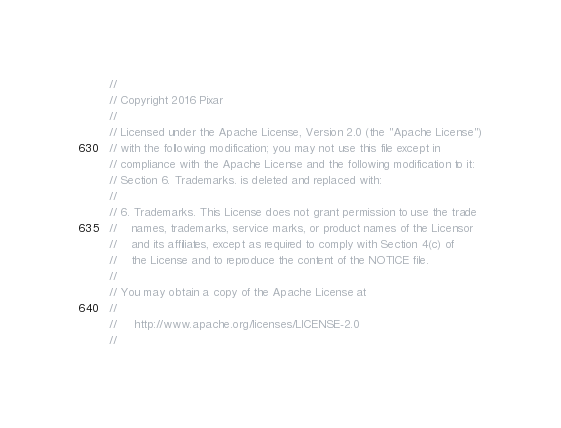Convert code to text. <code><loc_0><loc_0><loc_500><loc_500><_C_>//
// Copyright 2016 Pixar
//
// Licensed under the Apache License, Version 2.0 (the "Apache License")
// with the following modification; you may not use this file except in
// compliance with the Apache License and the following modification to it:
// Section 6. Trademarks. is deleted and replaced with:
//
// 6. Trademarks. This License does not grant permission to use the trade
//    names, trademarks, service marks, or product names of the Licensor
//    and its affiliates, except as required to comply with Section 4(c) of
//    the License and to reproduce the content of the NOTICE file.
//
// You may obtain a copy of the Apache License at
//
//     http://www.apache.org/licenses/LICENSE-2.0
//</code> 